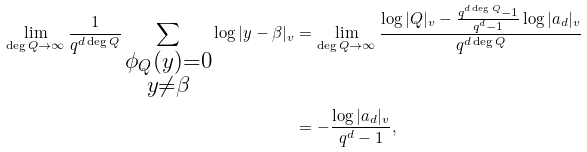<formula> <loc_0><loc_0><loc_500><loc_500>\lim _ { \deg Q \rightarrow \infty } \frac { 1 } { q ^ { d \deg Q } } \sum _ { \substack { \phi _ { Q } ( y ) = 0 \\ y \ne \beta } } \log | y - \beta | _ { v } & = \lim _ { \deg Q \rightarrow \infty } \frac { \log | Q | _ { v } - \frac { q ^ { d \deg Q } - 1 } { q ^ { d } - 1 } \log | a _ { d } | _ { v } } { q ^ { d \deg Q } } \\ & = - \frac { \log | a _ { d } | _ { v } } { q ^ { d } - 1 } ,</formula> 